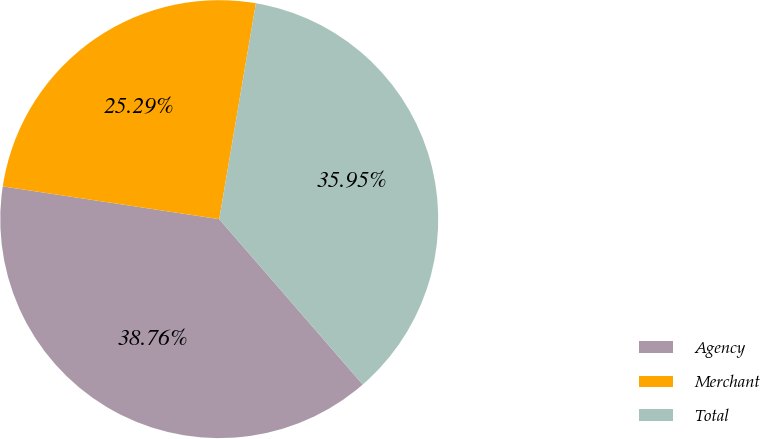<chart> <loc_0><loc_0><loc_500><loc_500><pie_chart><fcel>Agency<fcel>Merchant<fcel>Total<nl><fcel>38.76%<fcel>25.29%<fcel>35.95%<nl></chart> 